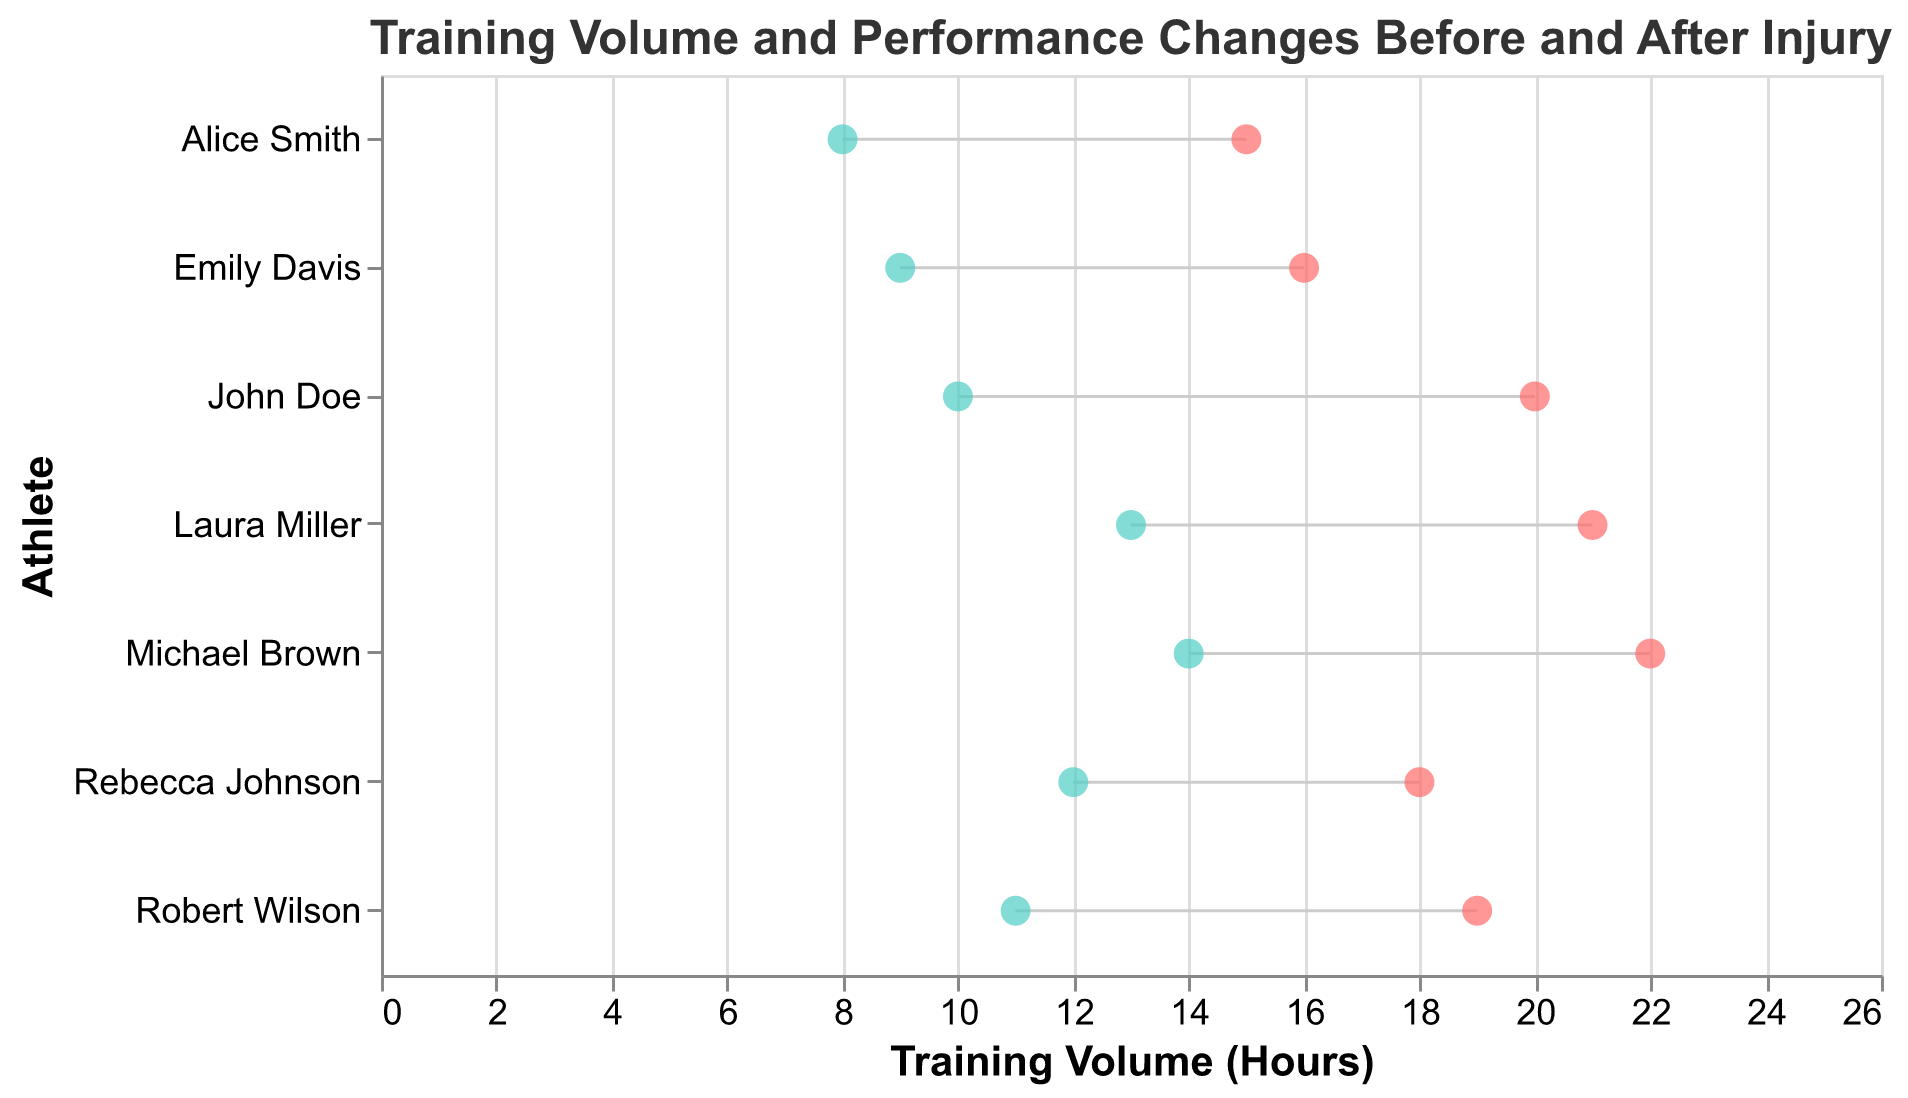How many athletes are shown in the plot? The plot shows the training volume and performance changes for multiple athletes. By counting the distinct y-axis labels, one can see there are 7 athletes.
Answer: 7 Which athlete had the highest training volume before injury? Look at the 'Training Volume (Hours) Before Injury' for each athlete. The maximum value is 22 hours, which corresponds to Michael Brown.
Answer: Michael Brown What is the difference in performance score for Emily Davis before and after the injury? Locate Emily Davis, compare her 'Performance Score Before Injury' (86) and 'Performance Score After Injury' (79). The difference is 86 - 79 = 7.
Answer: 7 What is the average training volume after injury across all athletes? Add the 'Training Volume (Hours) After Injury' for all athletes (8 + 10 + 12 + 14 + 9 + 11 + 13) and divide by 7. The total is 77, and the average is 77/7 = 11.
Answer: 11 Did any athlete maintain the same performance score after the injury? Compare 'Performance Score Before Injury' and 'Performance Score After Injury' for each athlete. No pairing of the same values exists, so none maintained the same score.
Answer: No Which athlete had the smallest reduction in training volume after the injury? Subtract 'Training Volume (Hours) After Injury' from 'Training Volume (Hours) Before Injury' for each athlete. The smallest reduction (6 hours) belongs to Rebecca Johnson (18 - 12).
Answer: Rebecca Johnson How much did John Doe's performance score decrease after the injury compared to Robert Wilson's? Calculate the difference for each: John Doe's performance score decreased by 90 - 82 = 8, and Robert Wilson's by 89 - 81 = 8. Difference is 8 - 8 = 0.
Answer: 0 What is the sum of the performance scores before injury for all athletes? Add the 'Performance Score Before Injury' values for each athlete (85 + 90 + 88 + 92 + 86 + 89 + 91). The total is 621.
Answer: 621 Who is the athlete with the lowest training volume after injury? Examine the 'Training Volume (Hours) After Injury' for all athletes. The lowest value is 8 hours, which corresponds to Alice Smith.
Answer: Alice Smith 